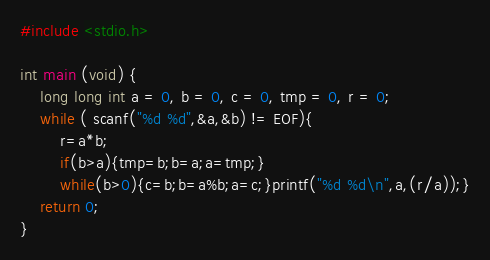Convert code to text. <code><loc_0><loc_0><loc_500><loc_500><_C_>#include <stdio.h>
 
int main (void) {
	long long int a = 0, b = 0, c = 0, tmp = 0, r = 0;
	while ( scanf("%d %d",&a,&b) != EOF){
		r=a*b;
		if(b>a){tmp=b;b=a;a=tmp;}
		while(b>0){c=b;b=a%b;a=c;}printf("%d %d\n",a,(r/a));}
	return 0;
}</code> 